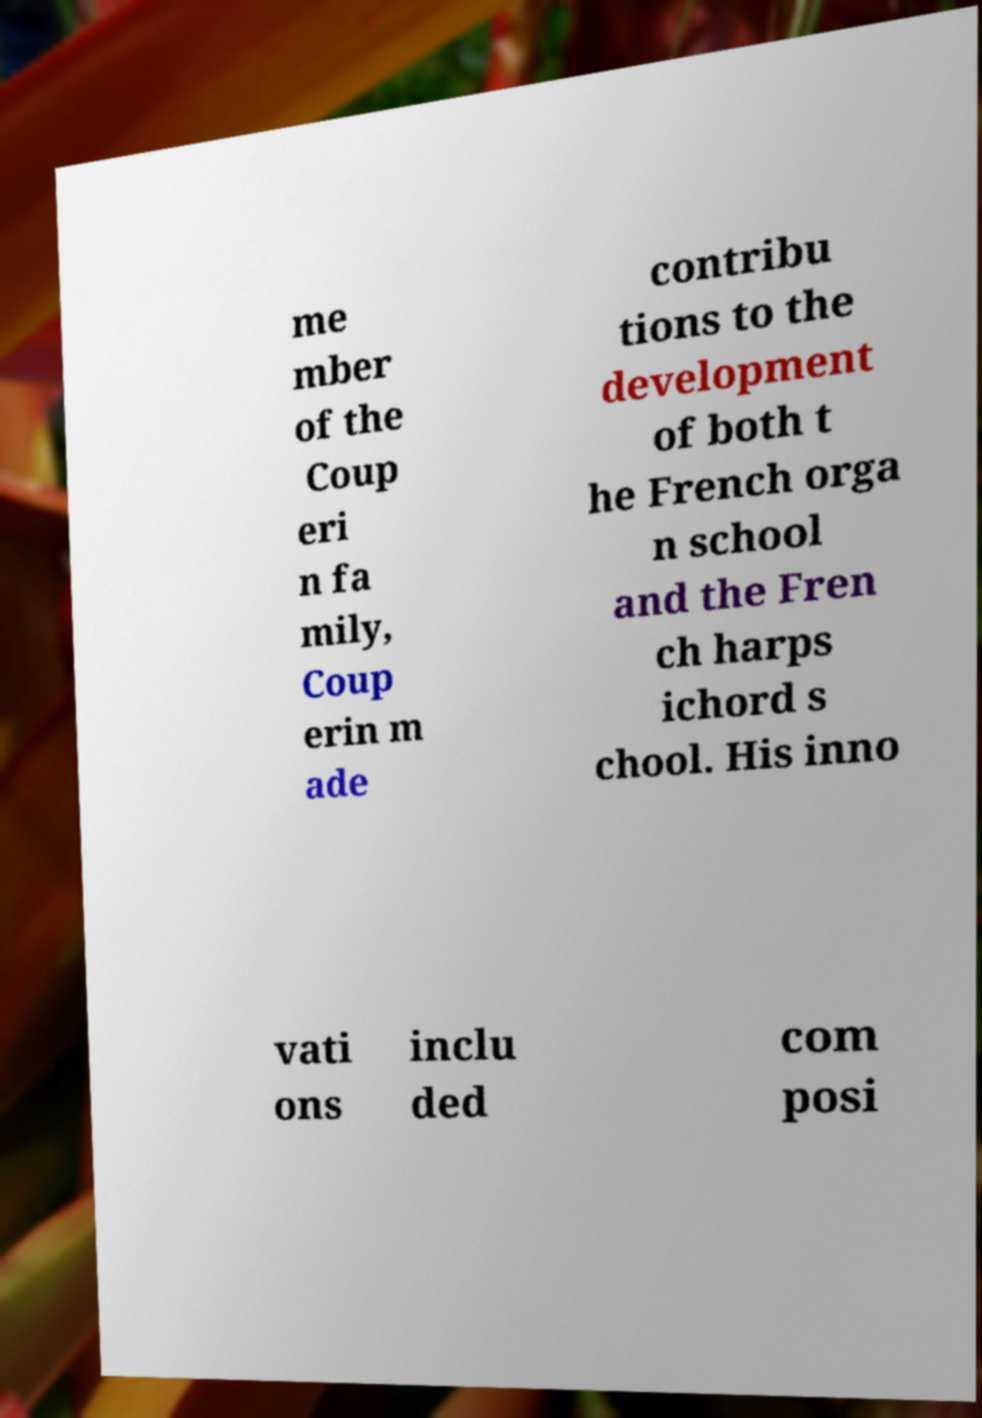Could you assist in decoding the text presented in this image and type it out clearly? me mber of the Coup eri n fa mily, Coup erin m ade contribu tions to the development of both t he French orga n school and the Fren ch harps ichord s chool. His inno vati ons inclu ded com posi 